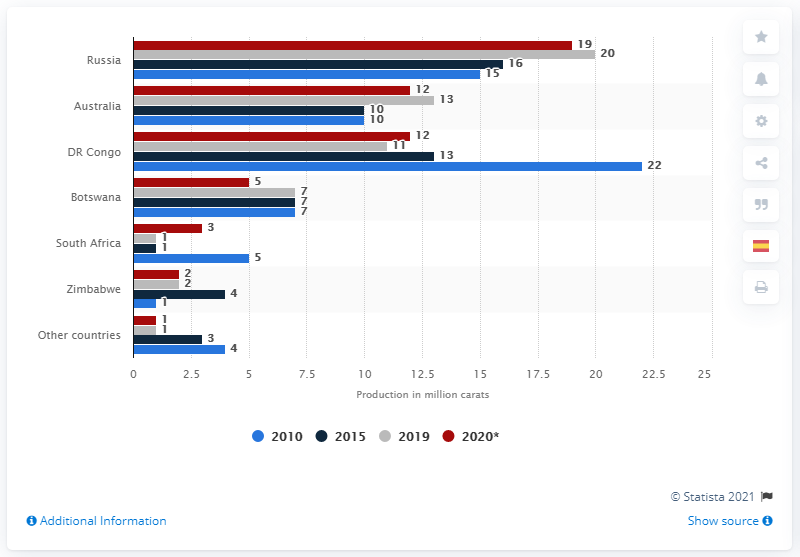Give some essential details in this illustration. In 2020, Russian mines produced a significant amount of carats of diamonds, as evidenced by the numerical value provided. 